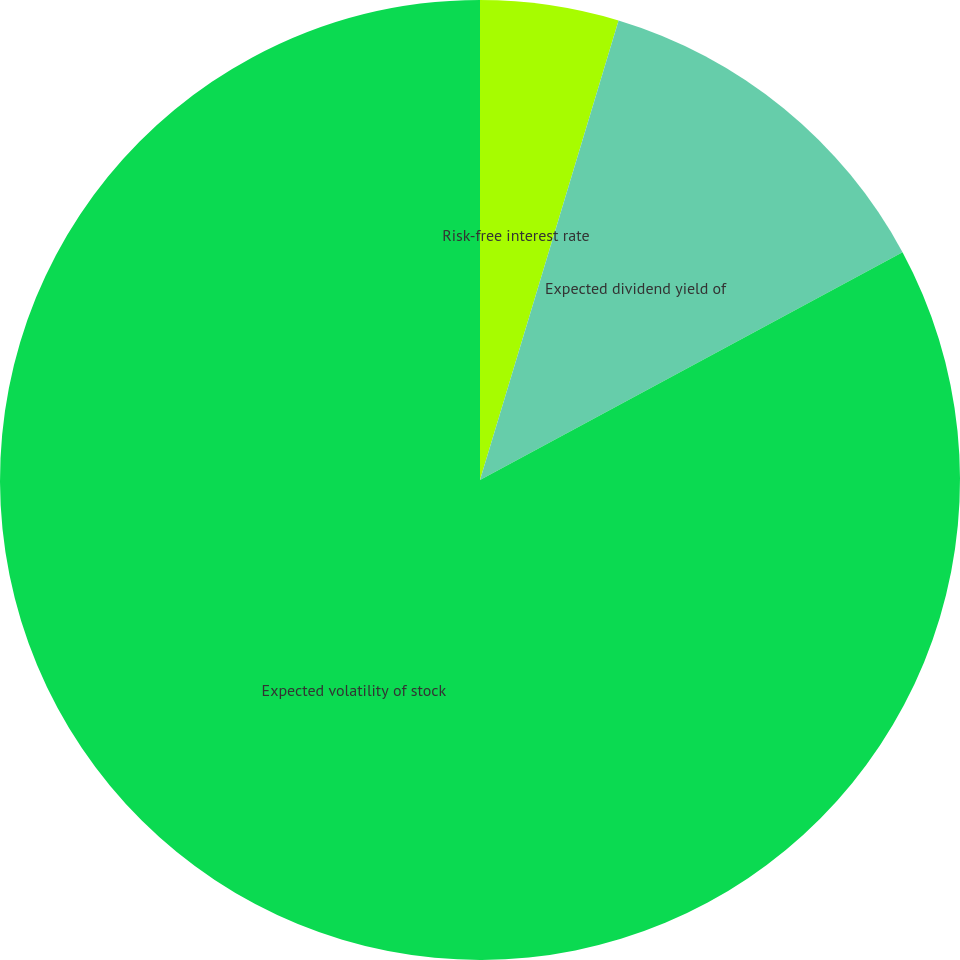<chart> <loc_0><loc_0><loc_500><loc_500><pie_chart><fcel>Risk-free interest rate<fcel>Expected dividend yield of<fcel>Expected volatility of stock<nl><fcel>4.66%<fcel>12.47%<fcel>82.86%<nl></chart> 